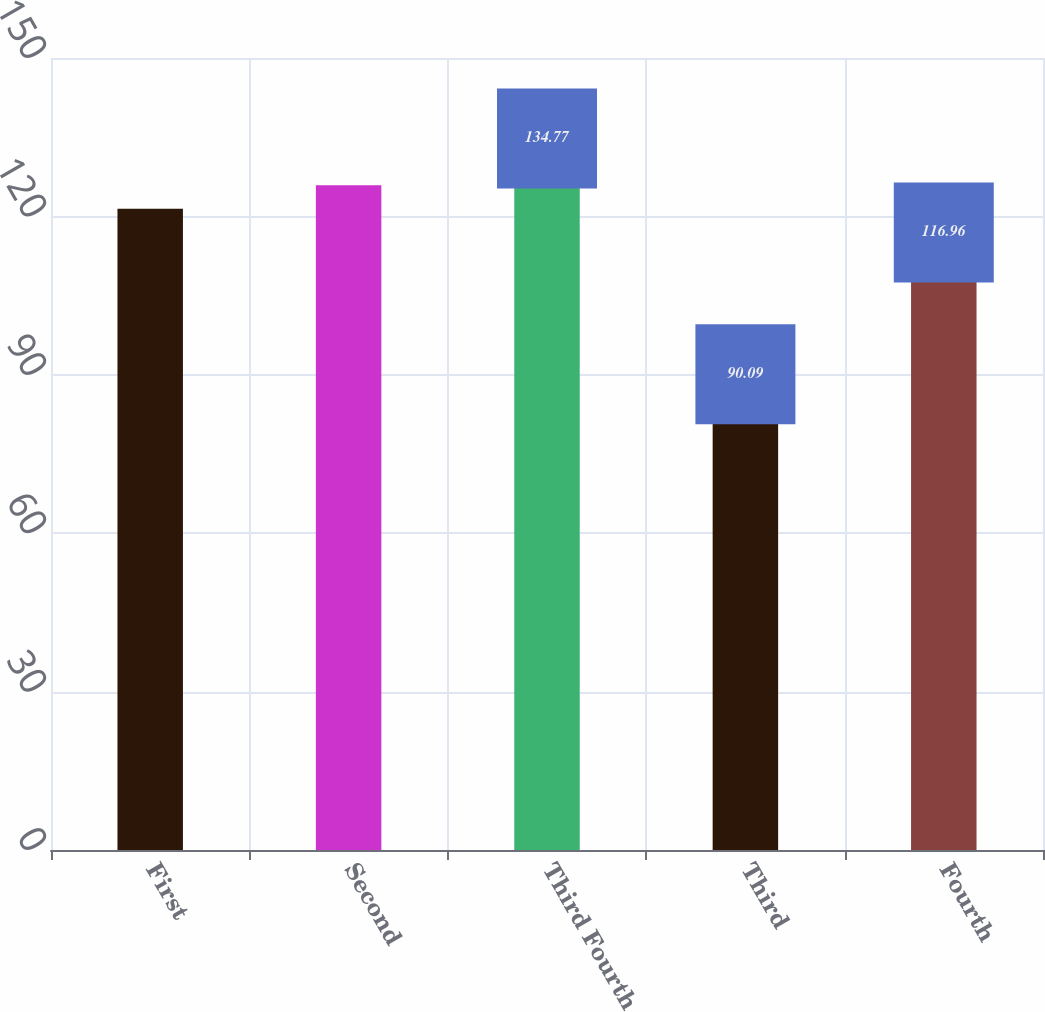Convert chart. <chart><loc_0><loc_0><loc_500><loc_500><bar_chart><fcel>First<fcel>Second<fcel>Third Fourth<fcel>Third<fcel>Fourth<nl><fcel>121.43<fcel>125.9<fcel>134.77<fcel>90.09<fcel>116.96<nl></chart> 